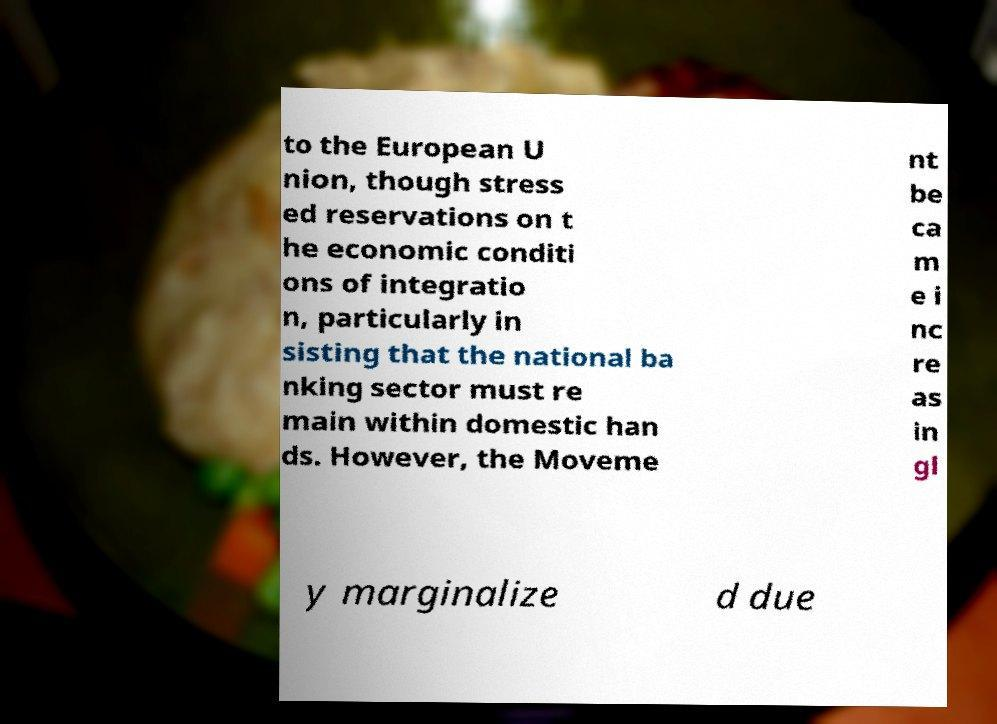Please identify and transcribe the text found in this image. to the European U nion, though stress ed reservations on t he economic conditi ons of integratio n, particularly in sisting that the national ba nking sector must re main within domestic han ds. However, the Moveme nt be ca m e i nc re as in gl y marginalize d due 